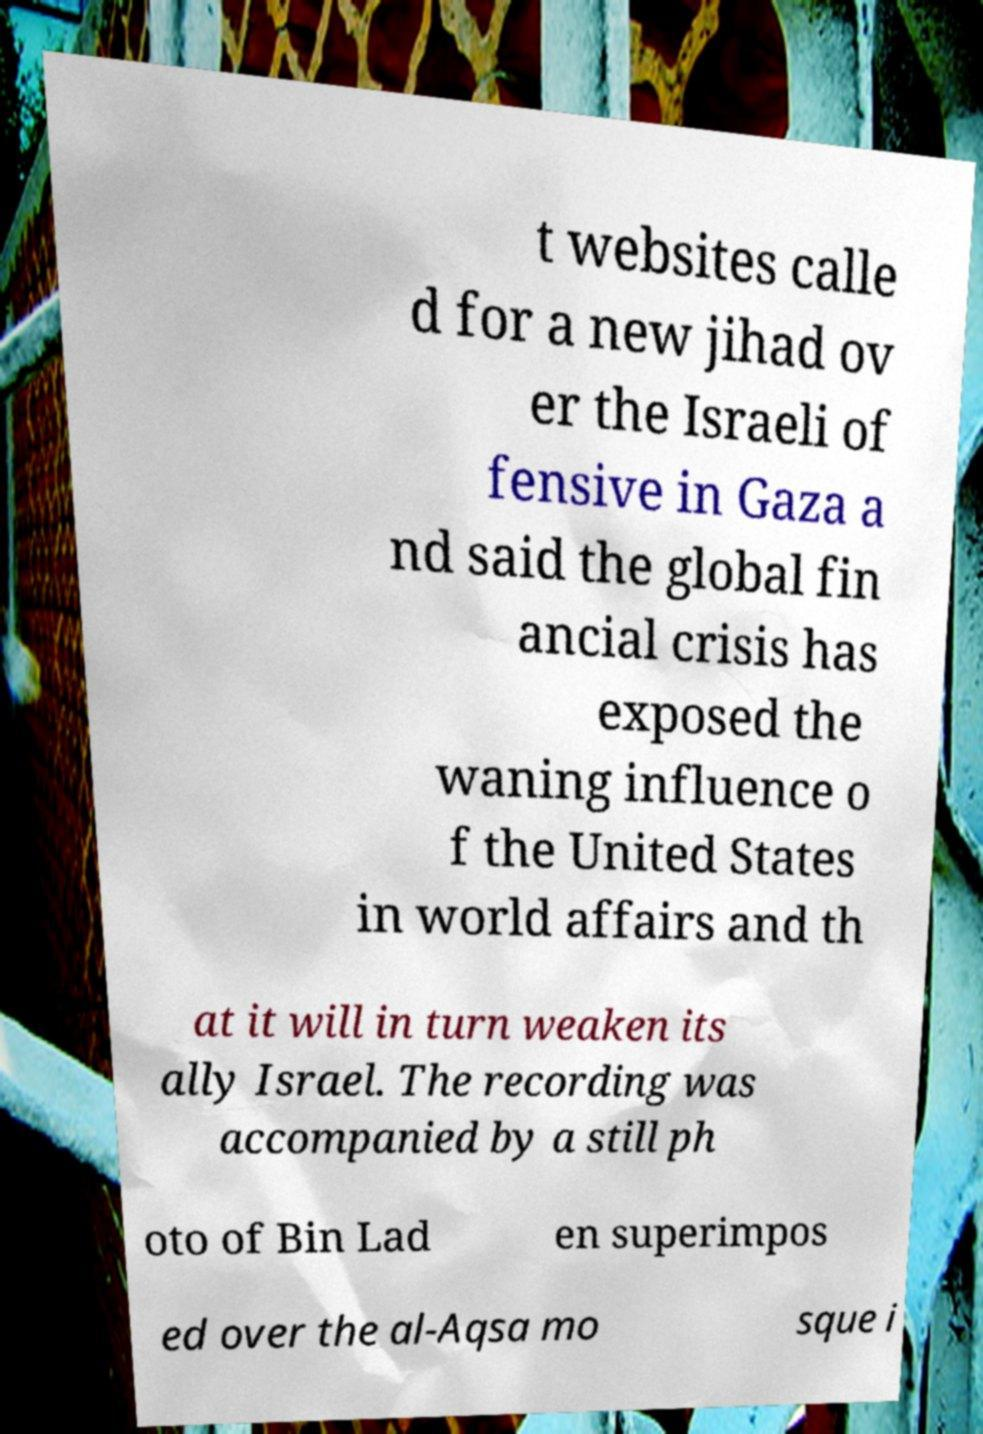Could you assist in decoding the text presented in this image and type it out clearly? t websites calle d for a new jihad ov er the Israeli of fensive in Gaza a nd said the global fin ancial crisis has exposed the waning influence o f the United States in world affairs and th at it will in turn weaken its ally Israel. The recording was accompanied by a still ph oto of Bin Lad en superimpos ed over the al-Aqsa mo sque i 